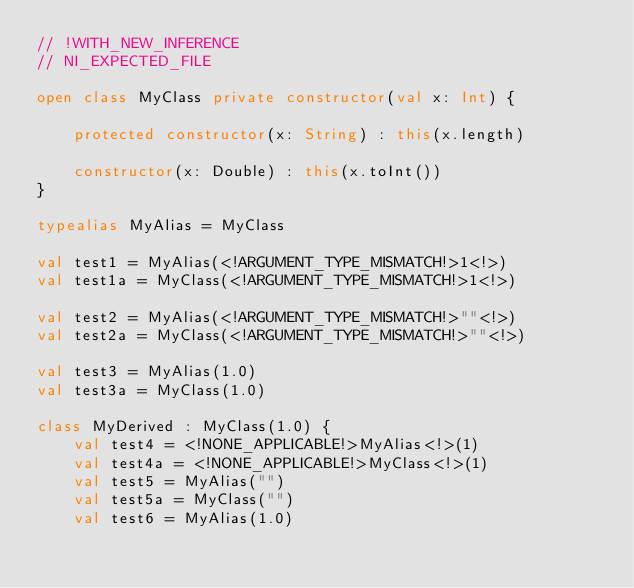<code> <loc_0><loc_0><loc_500><loc_500><_Kotlin_>// !WITH_NEW_INFERENCE
// NI_EXPECTED_FILE

open class MyClass private constructor(val x: Int) {

    protected constructor(x: String) : this(x.length)

    constructor(x: Double) : this(x.toInt())
}

typealias MyAlias = MyClass

val test1 = MyAlias(<!ARGUMENT_TYPE_MISMATCH!>1<!>)
val test1a = MyClass(<!ARGUMENT_TYPE_MISMATCH!>1<!>)

val test2 = MyAlias(<!ARGUMENT_TYPE_MISMATCH!>""<!>)
val test2a = MyClass(<!ARGUMENT_TYPE_MISMATCH!>""<!>)

val test3 = MyAlias(1.0)
val test3a = MyClass(1.0)

class MyDerived : MyClass(1.0) {
    val test4 = <!NONE_APPLICABLE!>MyAlias<!>(1)
    val test4a = <!NONE_APPLICABLE!>MyClass<!>(1)
    val test5 = MyAlias("")
    val test5a = MyClass("")
    val test6 = MyAlias(1.0)</code> 